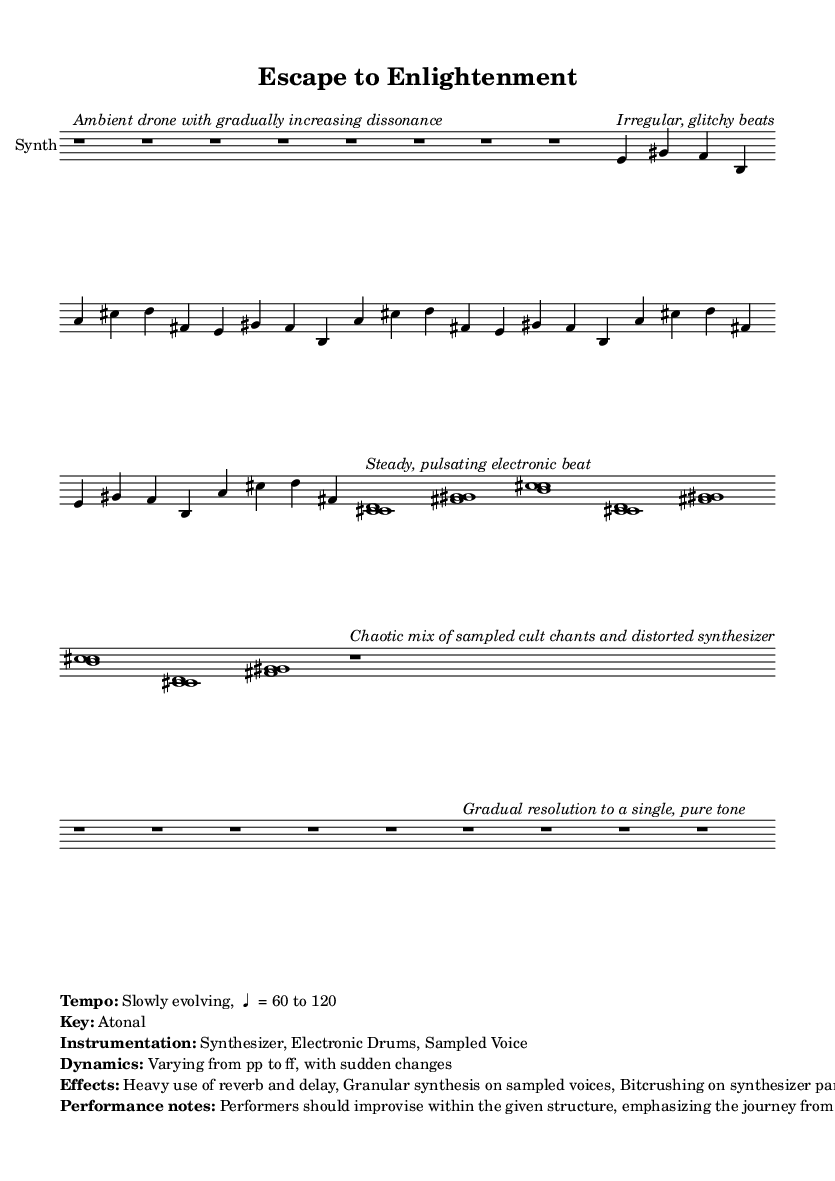What is the title of the composition? The title is provided in the header section of the sheet music. It reads "Escape to Enlightenment".
Answer: Escape to Enlightenment What is the time signature of the music? The time signature is displayed as "4/4" at the beginning of the melody. This indicates that there are four beats in each measure.
Answer: 4/4 What is the key of the piece? The key signature is indicated as "Atonal" in the markup notes, which means there isn't a specific key relating to major or minor scales.
Answer: Atonal How many bars are in the intro section? The intro section consists of 8 bars, as indicated by the musical notation in that part of the sheet music.
Answer: 8 What type of instrumentation is used? The instrumentation is specified in the markup as "Synthesizer, Electronic Drums, Sampled Voice". This tells us the instruments involved in the composition.
Answer: Synthesizer, Electronic Drums, Sampled Voice What dynamic range is indicated in the score? The dynamics are described as varying from "pp to ff", which stands for pianissimo to fortissimo, hence a wide dynamic range is indicated.
Answer: pp to ff What is the primary theme explored in this composition? The primary themes are mentioned in the markup as "freedom and self-discovery". This indicates the overall concept being explored through the music.
Answer: freedom and self-discovery 